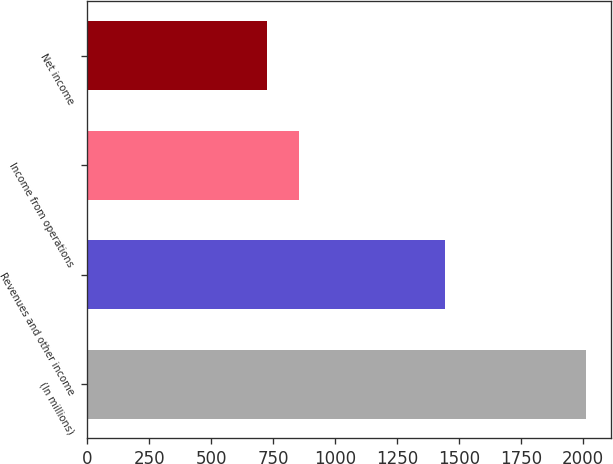<chart> <loc_0><loc_0><loc_500><loc_500><bar_chart><fcel>(In millions)<fcel>Revenues and other income<fcel>Income from operations<fcel>Net income<nl><fcel>2013<fcel>1444<fcel>855.6<fcel>727<nl></chart> 